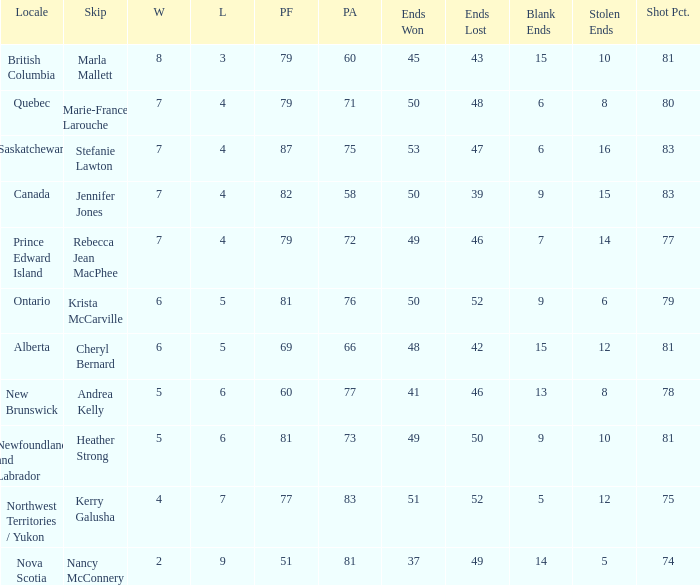Where was the 78% shot percentage located? New Brunswick. 